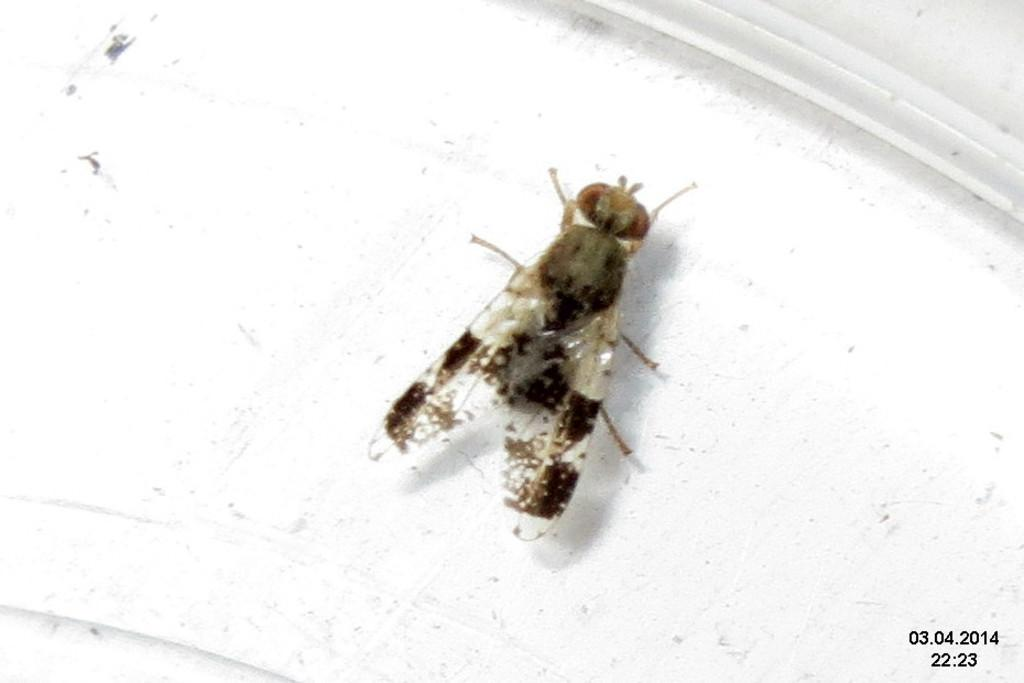What is present on the white surface in the image? There is a house fly on a white surface in the image. What additional information can be found on the image? There are watermarks on the right side bottom corner of the image. What do the watermarks indicate? The watermarks represent date and time. What type of tramp can be seen in the library on the page of the image? There is no tramp, library, or page present in the image; it only features a house fly on a white surface and watermarks representing date and time. 